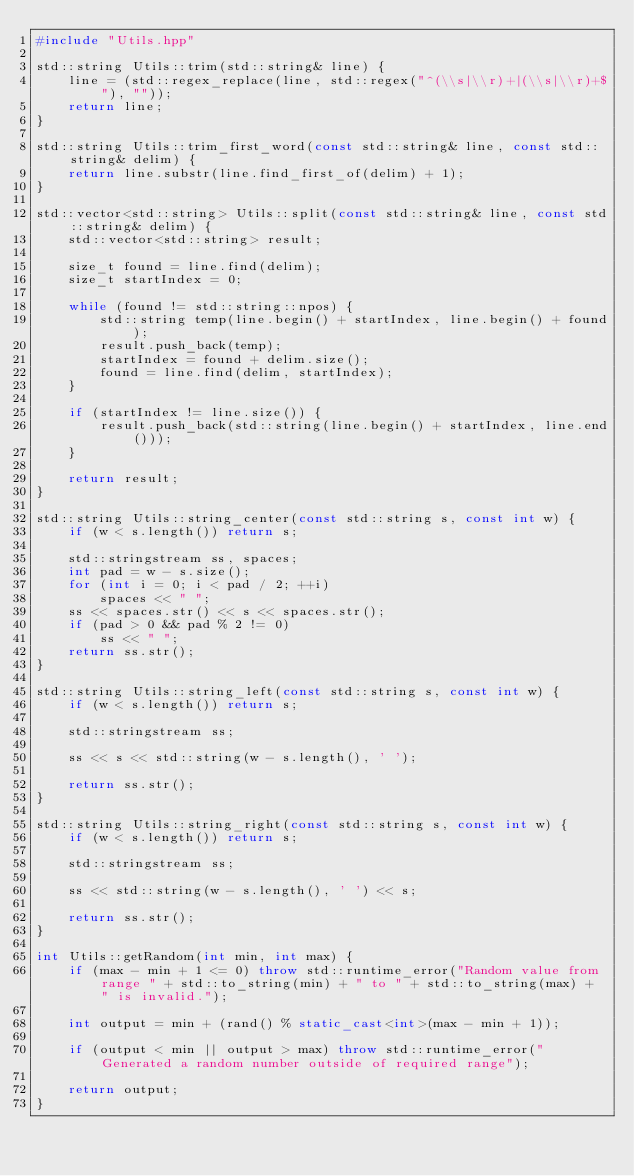<code> <loc_0><loc_0><loc_500><loc_500><_C++_>#include "Utils.hpp"

std::string Utils::trim(std::string& line) {
    line = (std::regex_replace(line, std::regex("^(\\s|\\r)+|(\\s|\\r)+$"), ""));
    return line;
}

std::string Utils::trim_first_word(const std::string& line, const std::string& delim) {
    return line.substr(line.find_first_of(delim) + 1);
}

std::vector<std::string> Utils::split(const std::string& line, const std::string& delim) {
    std::vector<std::string> result;

    size_t found = line.find(delim);
    size_t startIndex = 0;

    while (found != std::string::npos) {
        std::string temp(line.begin() + startIndex, line.begin() + found);
        result.push_back(temp);
        startIndex = found + delim.size();
        found = line.find(delim, startIndex);
    }

    if (startIndex != line.size()) {
        result.push_back(std::string(line.begin() + startIndex, line.end()));
    }

    return result;
}

std::string Utils::string_center(const std::string s, const int w) {
    if (w < s.length()) return s;

    std::stringstream ss, spaces;
    int pad = w - s.size();
    for (int i = 0; i < pad / 2; ++i)
        spaces << " ";
    ss << spaces.str() << s << spaces.str();
    if (pad > 0 && pad % 2 != 0)
        ss << " ";
    return ss.str();
}

std::string Utils::string_left(const std::string s, const int w) {
    if (w < s.length()) return s;

    std::stringstream ss;

    ss << s << std::string(w - s.length(), ' ');

    return ss.str();
}

std::string Utils::string_right(const std::string s, const int w) {
    if (w < s.length()) return s;

    std::stringstream ss;

    ss << std::string(w - s.length(), ' ') << s;

    return ss.str();
}

int Utils::getRandom(int min, int max) {
    if (max - min + 1 <= 0) throw std::runtime_error("Random value from range " + std::to_string(min) + " to " + std::to_string(max) + " is invalid.");

    int output = min + (rand() % static_cast<int>(max - min + 1));

    if (output < min || output > max) throw std::runtime_error("Generated a random number outside of required range");

    return output;
}

</code> 